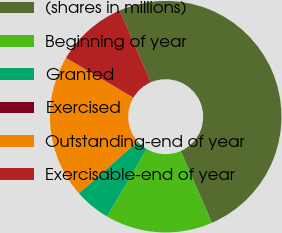<chart> <loc_0><loc_0><loc_500><loc_500><pie_chart><fcel>(shares in millions)<fcel>Beginning of year<fcel>Granted<fcel>Exercised<fcel>Outstanding-end of year<fcel>Exercisable-end of year<nl><fcel>49.96%<fcel>15.0%<fcel>5.01%<fcel>0.02%<fcel>20.0%<fcel>10.01%<nl></chart> 